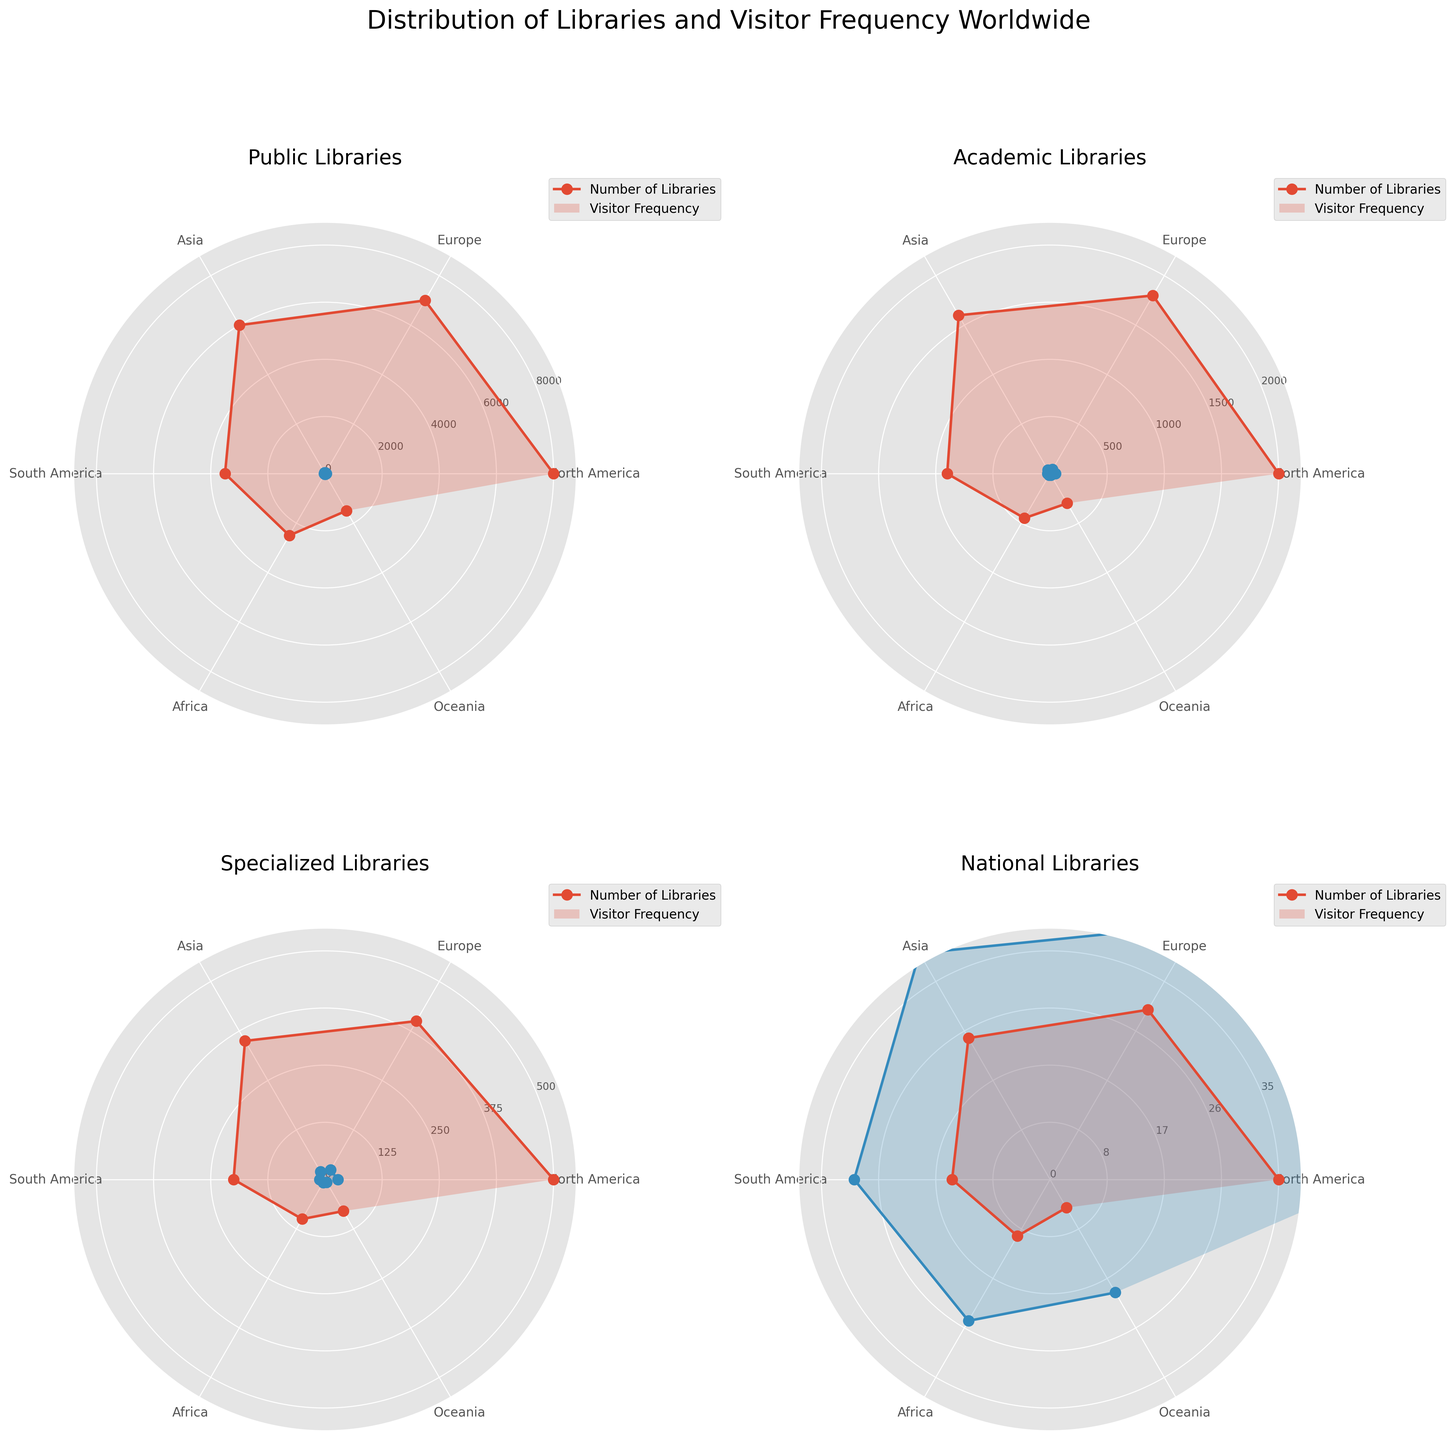What is the title of the figure? The title is displayed at the top of the figure. It reads "Distribution of Libraries and Visitor Frequency Worldwide".
Answer: Distribution of Libraries and Visitor Frequency Worldwide What types of libraries are included in the figure? The titles of the subplots indicate the types of libraries included. There are four types: Public Libraries, Academic Libraries, Specialized Libraries, and National Libraries.
Answer: Public, Academic, Specialized, National Which region has the highest number of Public Libraries? In the subplot titled "Public Libraries", the highest point on the radial axis corresponds to North America.
Answer: North America Which region has the lowest Visitor Frequency for Academic Libraries? In the subplot titled "Academic Libraries", the lowest point on the Visitor Frequency line corresponds to Oceania.
Answer: Oceania How does the Visitor Frequency of National Libraries in North America compare to that in Africa? In the subplot titled "National Libraries", the Visitor Frequency for North America is at the highest point, while Africa is at a lower point.
Answer: Higher in North America On which subplot is the maximum radius for the number of libraries largest, and what is the radius? Comparing the radial axes for number of libraries across all subplots, the Public Libraries subplot has the largest maximum radius, which is around 8000.
Answer: Public Libraries, 8000 What is the average Visitor Frequency for Specialized Libraries across all regions? The Visitor Frequencies for Specialized Libraries are 28, 24, 20, 12, 8, and 7. The average is calculated as (28 + 24 + 20 + 12 + 8 + 7) / 6.
Answer: 16.5 Which type of library has the smallest variation in Visitor Frequency among different regions? By comparing the range of Visitor Frequencies in each subplot, National Libraries have the smallest variation, ranging from 20 to 50.
Answer: National Libraries What is the sum of the number of Academic Libraries in North America and Europe? The subplot titled "Academic Libraries" shows 2000 libraries in North America and 1800 in Europe. The sum is 2000 + 1800.
Answer: 3800 In which region do Public Libraries have the greatest difference between the number of libraries and Visitor Frequency? In the subplot titled "Public Libraries", North America shows the largest difference between the number of libraries (8000) and Visitor Frequency (45).
Answer: North America 